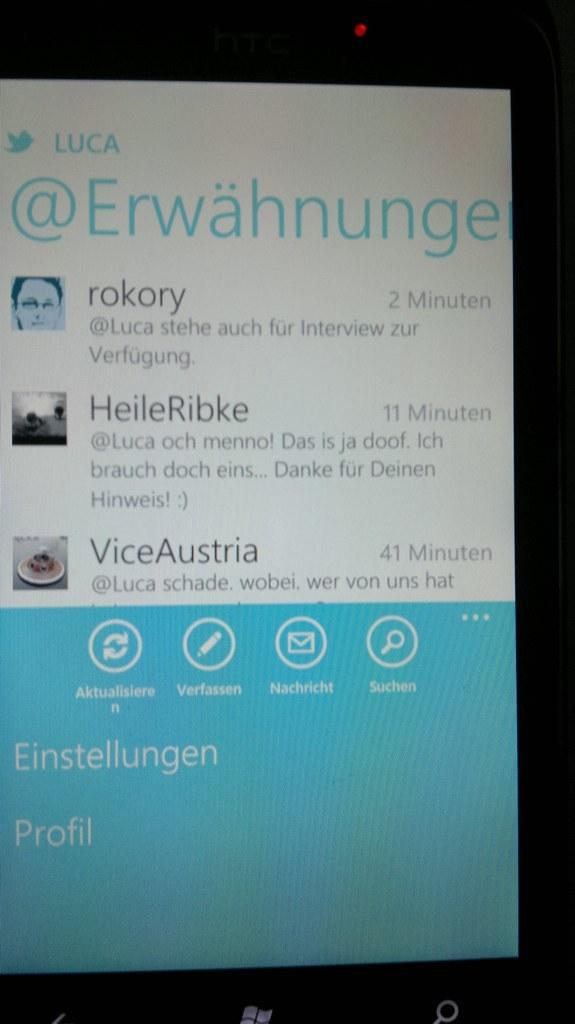<image>
Offer a succinct explanation of the picture presented. windows device showing twitter account of LUCA @Erwahnunge 